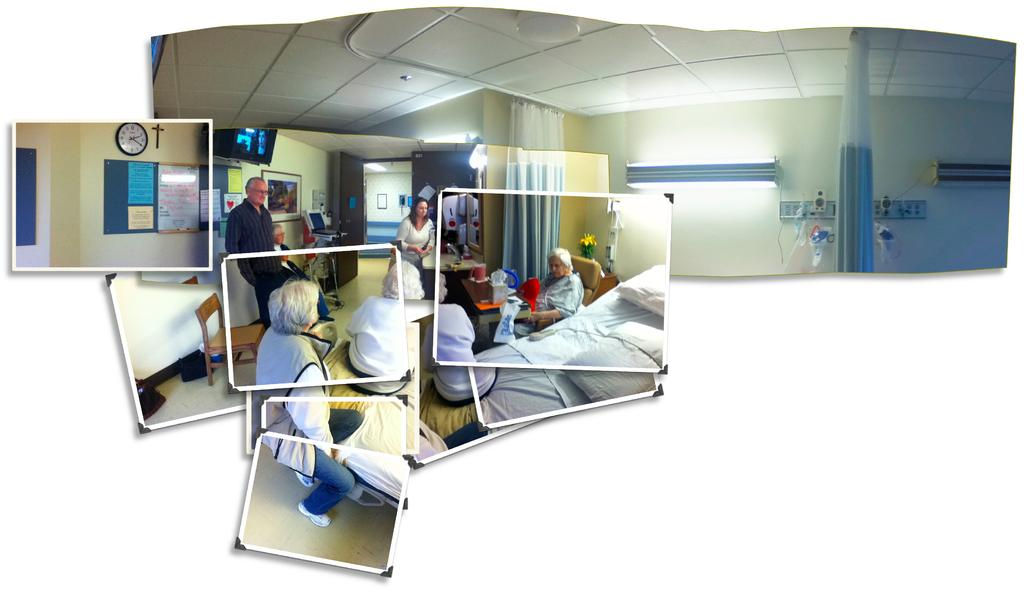What type of objects are present in the image? There are photographs and a bed in the image. What can be seen in the photographs? The photographs contain images of people, wall frames, and boards. What is on the bed? There are cushions on the bed. Are there any light sources visible in the image? Yes, there are lights visible in the image. What type of coil is used to cook the chicken in the image? There is no coil or chicken present in the image. Where is the lunchroom located in the image? The image does not depict a lunchroom; it contains photographs and a bed. 